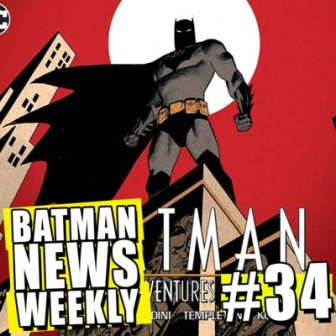Suppose this cover was a scene from a Batman movie. Write a dialogue for Batman as he stands atop the building. Batman (gazing over the city): 'Gotham’s pulse quickens at night. Shadows stretch longer, and criminals think they can hide in darkness. But they forget—I am the night. Every heartbeat of this city, every whisper in the alleys, I hear them. Tonight, justice will be served.' 